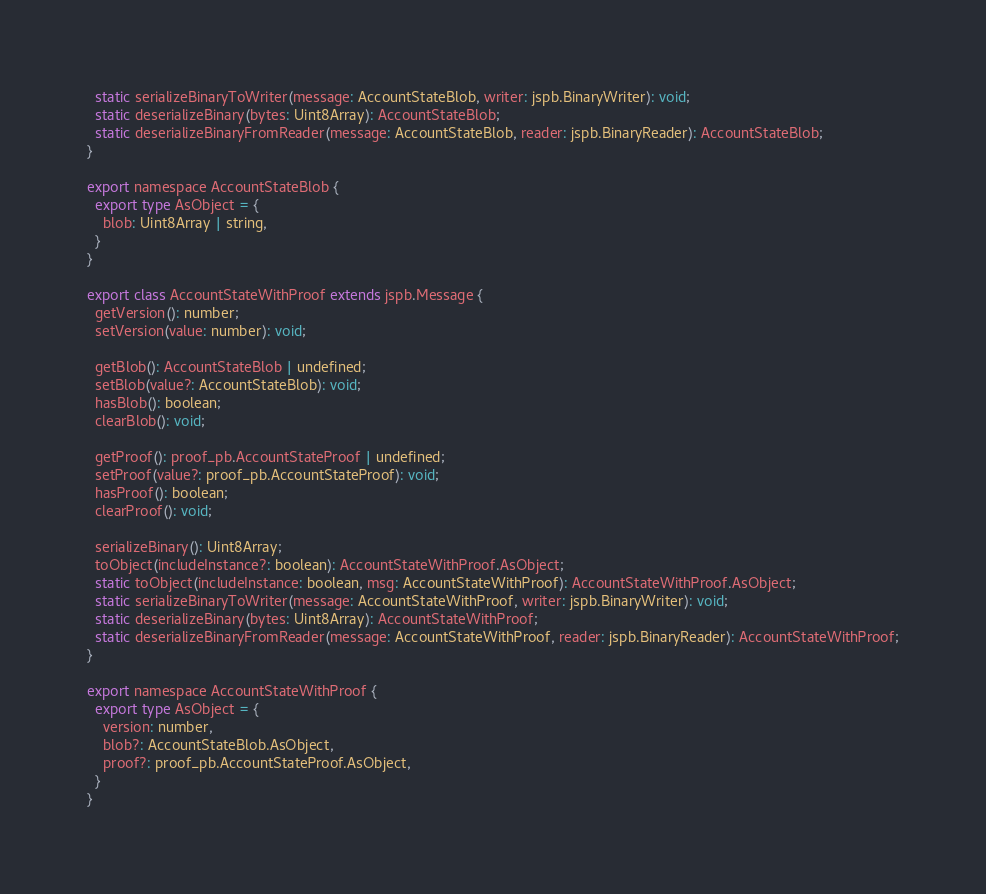<code> <loc_0><loc_0><loc_500><loc_500><_TypeScript_>  static serializeBinaryToWriter(message: AccountStateBlob, writer: jspb.BinaryWriter): void;
  static deserializeBinary(bytes: Uint8Array): AccountStateBlob;
  static deserializeBinaryFromReader(message: AccountStateBlob, reader: jspb.BinaryReader): AccountStateBlob;
}

export namespace AccountStateBlob {
  export type AsObject = {
    blob: Uint8Array | string,
  }
}

export class AccountStateWithProof extends jspb.Message {
  getVersion(): number;
  setVersion(value: number): void;

  getBlob(): AccountStateBlob | undefined;
  setBlob(value?: AccountStateBlob): void;
  hasBlob(): boolean;
  clearBlob(): void;

  getProof(): proof_pb.AccountStateProof | undefined;
  setProof(value?: proof_pb.AccountStateProof): void;
  hasProof(): boolean;
  clearProof(): void;

  serializeBinary(): Uint8Array;
  toObject(includeInstance?: boolean): AccountStateWithProof.AsObject;
  static toObject(includeInstance: boolean, msg: AccountStateWithProof): AccountStateWithProof.AsObject;
  static serializeBinaryToWriter(message: AccountStateWithProof, writer: jspb.BinaryWriter): void;
  static deserializeBinary(bytes: Uint8Array): AccountStateWithProof;
  static deserializeBinaryFromReader(message: AccountStateWithProof, reader: jspb.BinaryReader): AccountStateWithProof;
}

export namespace AccountStateWithProof {
  export type AsObject = {
    version: number,
    blob?: AccountStateBlob.AsObject,
    proof?: proof_pb.AccountStateProof.AsObject,
  }
}

</code> 